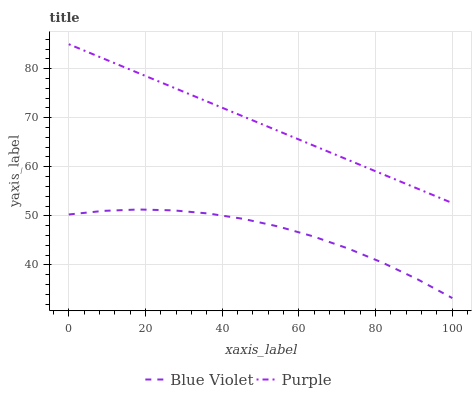Does Blue Violet have the minimum area under the curve?
Answer yes or no. Yes. Does Purple have the maximum area under the curve?
Answer yes or no. Yes. Does Blue Violet have the maximum area under the curve?
Answer yes or no. No. Is Purple the smoothest?
Answer yes or no. Yes. Is Blue Violet the roughest?
Answer yes or no. Yes. Is Blue Violet the smoothest?
Answer yes or no. No. Does Blue Violet have the lowest value?
Answer yes or no. Yes. Does Purple have the highest value?
Answer yes or no. Yes. Does Blue Violet have the highest value?
Answer yes or no. No. Is Blue Violet less than Purple?
Answer yes or no. Yes. Is Purple greater than Blue Violet?
Answer yes or no. Yes. Does Blue Violet intersect Purple?
Answer yes or no. No. 